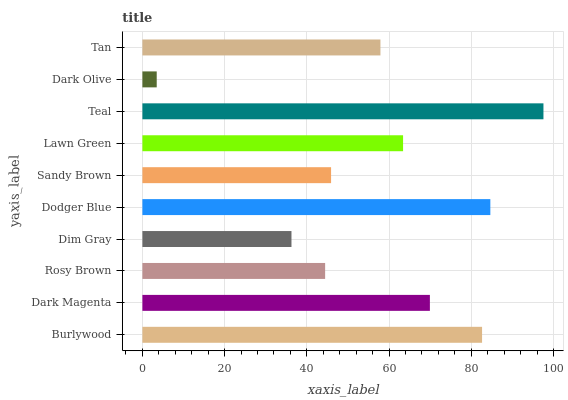Is Dark Olive the minimum?
Answer yes or no. Yes. Is Teal the maximum?
Answer yes or no. Yes. Is Dark Magenta the minimum?
Answer yes or no. No. Is Dark Magenta the maximum?
Answer yes or no. No. Is Burlywood greater than Dark Magenta?
Answer yes or no. Yes. Is Dark Magenta less than Burlywood?
Answer yes or no. Yes. Is Dark Magenta greater than Burlywood?
Answer yes or no. No. Is Burlywood less than Dark Magenta?
Answer yes or no. No. Is Lawn Green the high median?
Answer yes or no. Yes. Is Tan the low median?
Answer yes or no. Yes. Is Dark Magenta the high median?
Answer yes or no. No. Is Dodger Blue the low median?
Answer yes or no. No. 